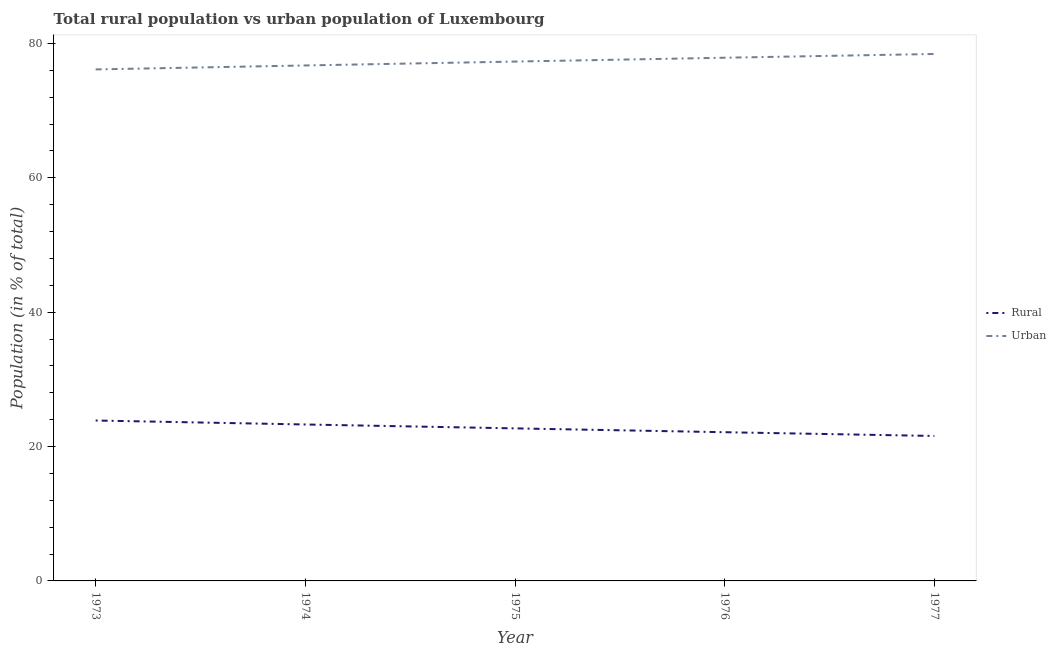How many different coloured lines are there?
Provide a short and direct response. 2. Does the line corresponding to urban population intersect with the line corresponding to rural population?
Give a very brief answer. No. What is the urban population in 1976?
Offer a terse response. 77.87. Across all years, what is the maximum rural population?
Provide a short and direct response. 23.87. Across all years, what is the minimum rural population?
Your response must be concise. 21.57. In which year was the rural population maximum?
Your answer should be compact. 1973. In which year was the urban population minimum?
Offer a very short reply. 1973. What is the total urban population in the graph?
Give a very brief answer. 386.43. What is the difference between the rural population in 1974 and that in 1975?
Your response must be concise. 0.58. What is the difference between the urban population in 1974 and the rural population in 1976?
Give a very brief answer. 54.58. What is the average rural population per year?
Keep it short and to the point. 22.71. In the year 1977, what is the difference between the urban population and rural population?
Offer a terse response. 56.85. In how many years, is the urban population greater than 48 %?
Offer a very short reply. 5. What is the ratio of the rural population in 1973 to that in 1976?
Provide a succinct answer. 1.08. Is the difference between the urban population in 1973 and 1975 greater than the difference between the rural population in 1973 and 1975?
Offer a terse response. No. What is the difference between the highest and the second highest rural population?
Your answer should be compact. 0.59. What is the difference between the highest and the lowest rural population?
Ensure brevity in your answer.  2.3. Is the sum of the rural population in 1974 and 1975 greater than the maximum urban population across all years?
Your response must be concise. No. Is the urban population strictly greater than the rural population over the years?
Offer a terse response. Yes. What is the difference between two consecutive major ticks on the Y-axis?
Give a very brief answer. 20. Are the values on the major ticks of Y-axis written in scientific E-notation?
Ensure brevity in your answer.  No. How are the legend labels stacked?
Offer a very short reply. Vertical. What is the title of the graph?
Provide a short and direct response. Total rural population vs urban population of Luxembourg. What is the label or title of the X-axis?
Your answer should be very brief. Year. What is the label or title of the Y-axis?
Give a very brief answer. Population (in % of total). What is the Population (in % of total) of Rural in 1973?
Your response must be concise. 23.87. What is the Population (in % of total) of Urban in 1973?
Give a very brief answer. 76.13. What is the Population (in % of total) in Rural in 1974?
Keep it short and to the point. 23.28. What is the Population (in % of total) in Urban in 1974?
Your answer should be very brief. 76.72. What is the Population (in % of total) in Rural in 1975?
Provide a short and direct response. 22.7. What is the Population (in % of total) of Urban in 1975?
Offer a terse response. 77.3. What is the Population (in % of total) in Rural in 1976?
Offer a very short reply. 22.13. What is the Population (in % of total) in Urban in 1976?
Provide a short and direct response. 77.87. What is the Population (in % of total) of Rural in 1977?
Your answer should be very brief. 21.57. What is the Population (in % of total) of Urban in 1977?
Provide a short and direct response. 78.43. Across all years, what is the maximum Population (in % of total) in Rural?
Your answer should be compact. 23.87. Across all years, what is the maximum Population (in % of total) in Urban?
Your response must be concise. 78.43. Across all years, what is the minimum Population (in % of total) in Rural?
Offer a very short reply. 21.57. Across all years, what is the minimum Population (in % of total) in Urban?
Provide a short and direct response. 76.13. What is the total Population (in % of total) of Rural in the graph?
Give a very brief answer. 113.57. What is the total Population (in % of total) of Urban in the graph?
Your response must be concise. 386.43. What is the difference between the Population (in % of total) of Rural in 1973 and that in 1974?
Provide a succinct answer. 0.59. What is the difference between the Population (in % of total) of Urban in 1973 and that in 1974?
Keep it short and to the point. -0.59. What is the difference between the Population (in % of total) of Rural in 1973 and that in 1975?
Your answer should be very brief. 1.17. What is the difference between the Population (in % of total) of Urban in 1973 and that in 1975?
Offer a terse response. -1.17. What is the difference between the Population (in % of total) in Rural in 1973 and that in 1976?
Provide a succinct answer. 1.74. What is the difference between the Population (in % of total) in Urban in 1973 and that in 1976?
Provide a short and direct response. -1.74. What is the difference between the Population (in % of total) in Rural in 1973 and that in 1977?
Keep it short and to the point. 2.3. What is the difference between the Population (in % of total) of Urban in 1973 and that in 1977?
Give a very brief answer. -2.3. What is the difference between the Population (in % of total) in Rural in 1974 and that in 1975?
Provide a succinct answer. 0.58. What is the difference between the Population (in % of total) of Urban in 1974 and that in 1975?
Provide a succinct answer. -0.58. What is the difference between the Population (in % of total) of Rural in 1974 and that in 1976?
Your response must be concise. 1.15. What is the difference between the Population (in % of total) of Urban in 1974 and that in 1976?
Your response must be concise. -1.15. What is the difference between the Population (in % of total) in Rural in 1974 and that in 1977?
Provide a short and direct response. 1.71. What is the difference between the Population (in % of total) in Urban in 1974 and that in 1977?
Provide a succinct answer. -1.71. What is the difference between the Population (in % of total) in Rural in 1975 and that in 1976?
Offer a terse response. 0.57. What is the difference between the Population (in % of total) of Urban in 1975 and that in 1976?
Provide a short and direct response. -0.57. What is the difference between the Population (in % of total) in Rural in 1975 and that in 1977?
Your answer should be very brief. 1.13. What is the difference between the Population (in % of total) of Urban in 1975 and that in 1977?
Provide a short and direct response. -1.13. What is the difference between the Population (in % of total) of Rural in 1976 and that in 1977?
Provide a short and direct response. 0.56. What is the difference between the Population (in % of total) of Urban in 1976 and that in 1977?
Give a very brief answer. -0.56. What is the difference between the Population (in % of total) in Rural in 1973 and the Population (in % of total) in Urban in 1974?
Offer a terse response. -52.84. What is the difference between the Population (in % of total) in Rural in 1973 and the Population (in % of total) in Urban in 1975?
Your answer should be compact. -53.42. What is the difference between the Population (in % of total) of Rural in 1973 and the Population (in % of total) of Urban in 1976?
Offer a terse response. -53.99. What is the difference between the Population (in % of total) of Rural in 1973 and the Population (in % of total) of Urban in 1977?
Give a very brief answer. -54.55. What is the difference between the Population (in % of total) of Rural in 1974 and the Population (in % of total) of Urban in 1975?
Provide a succinct answer. -54.01. What is the difference between the Population (in % of total) of Rural in 1974 and the Population (in % of total) of Urban in 1976?
Your response must be concise. -54.58. What is the difference between the Population (in % of total) of Rural in 1974 and the Population (in % of total) of Urban in 1977?
Keep it short and to the point. -55.14. What is the difference between the Population (in % of total) of Rural in 1975 and the Population (in % of total) of Urban in 1976?
Offer a very short reply. -55.16. What is the difference between the Population (in % of total) of Rural in 1975 and the Population (in % of total) of Urban in 1977?
Ensure brevity in your answer.  -55.72. What is the difference between the Population (in % of total) of Rural in 1976 and the Population (in % of total) of Urban in 1977?
Give a very brief answer. -56.29. What is the average Population (in % of total) in Rural per year?
Keep it short and to the point. 22.71. What is the average Population (in % of total) in Urban per year?
Your response must be concise. 77.29. In the year 1973, what is the difference between the Population (in % of total) of Rural and Population (in % of total) of Urban?
Give a very brief answer. -52.25. In the year 1974, what is the difference between the Population (in % of total) of Rural and Population (in % of total) of Urban?
Offer a terse response. -53.43. In the year 1975, what is the difference between the Population (in % of total) in Rural and Population (in % of total) in Urban?
Keep it short and to the point. -54.59. In the year 1976, what is the difference between the Population (in % of total) in Rural and Population (in % of total) in Urban?
Your answer should be compact. -55.73. In the year 1977, what is the difference between the Population (in % of total) in Rural and Population (in % of total) in Urban?
Your response must be concise. -56.85. What is the ratio of the Population (in % of total) of Rural in 1973 to that in 1974?
Offer a very short reply. 1.03. What is the ratio of the Population (in % of total) of Rural in 1973 to that in 1975?
Your answer should be compact. 1.05. What is the ratio of the Population (in % of total) of Urban in 1973 to that in 1975?
Keep it short and to the point. 0.98. What is the ratio of the Population (in % of total) of Rural in 1973 to that in 1976?
Keep it short and to the point. 1.08. What is the ratio of the Population (in % of total) of Urban in 1973 to that in 1976?
Provide a succinct answer. 0.98. What is the ratio of the Population (in % of total) in Rural in 1973 to that in 1977?
Provide a succinct answer. 1.11. What is the ratio of the Population (in % of total) of Urban in 1973 to that in 1977?
Ensure brevity in your answer.  0.97. What is the ratio of the Population (in % of total) in Rural in 1974 to that in 1975?
Give a very brief answer. 1.03. What is the ratio of the Population (in % of total) in Rural in 1974 to that in 1976?
Provide a succinct answer. 1.05. What is the ratio of the Population (in % of total) of Urban in 1974 to that in 1976?
Your answer should be very brief. 0.99. What is the ratio of the Population (in % of total) of Rural in 1974 to that in 1977?
Make the answer very short. 1.08. What is the ratio of the Population (in % of total) of Urban in 1974 to that in 1977?
Offer a terse response. 0.98. What is the ratio of the Population (in % of total) in Rural in 1975 to that in 1976?
Provide a succinct answer. 1.03. What is the ratio of the Population (in % of total) of Urban in 1975 to that in 1976?
Your response must be concise. 0.99. What is the ratio of the Population (in % of total) in Rural in 1975 to that in 1977?
Offer a terse response. 1.05. What is the ratio of the Population (in % of total) in Urban in 1975 to that in 1977?
Your answer should be compact. 0.99. What is the ratio of the Population (in % of total) of Rural in 1976 to that in 1977?
Ensure brevity in your answer.  1.03. What is the difference between the highest and the second highest Population (in % of total) of Rural?
Your answer should be very brief. 0.59. What is the difference between the highest and the second highest Population (in % of total) of Urban?
Provide a succinct answer. 0.56. What is the difference between the highest and the lowest Population (in % of total) of Rural?
Provide a succinct answer. 2.3. What is the difference between the highest and the lowest Population (in % of total) of Urban?
Give a very brief answer. 2.3. 